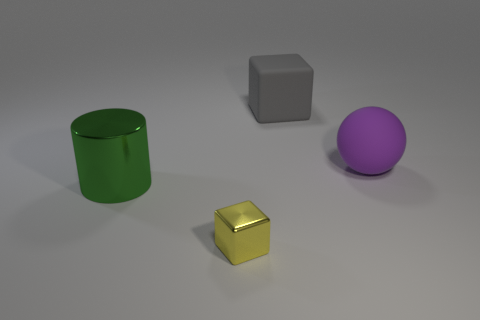Is the number of green metal cylinders that are behind the large shiny thing the same as the number of big metal cylinders on the right side of the large gray rubber block?
Provide a succinct answer. Yes. Are there more things right of the tiny yellow shiny cube than big yellow rubber spheres?
Provide a short and direct response. Yes. What is the small yellow thing made of?
Your answer should be very brief. Metal. What shape is the tiny yellow object that is made of the same material as the big green cylinder?
Ensure brevity in your answer.  Cube. There is a block that is in front of the big rubber thing that is left of the large ball; what size is it?
Give a very brief answer. Small. The large rubber thing that is in front of the big gray matte thing is what color?
Offer a very short reply. Purple. Are there any other matte things that have the same shape as the purple rubber thing?
Give a very brief answer. No. Is the number of purple spheres that are left of the big metal cylinder less than the number of large gray cubes right of the large purple ball?
Your response must be concise. No. The metal cube has what color?
Provide a short and direct response. Yellow. There is a matte object in front of the gray thing; are there any objects to the left of it?
Your answer should be very brief. Yes. 